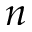<formula> <loc_0><loc_0><loc_500><loc_500>n</formula> 